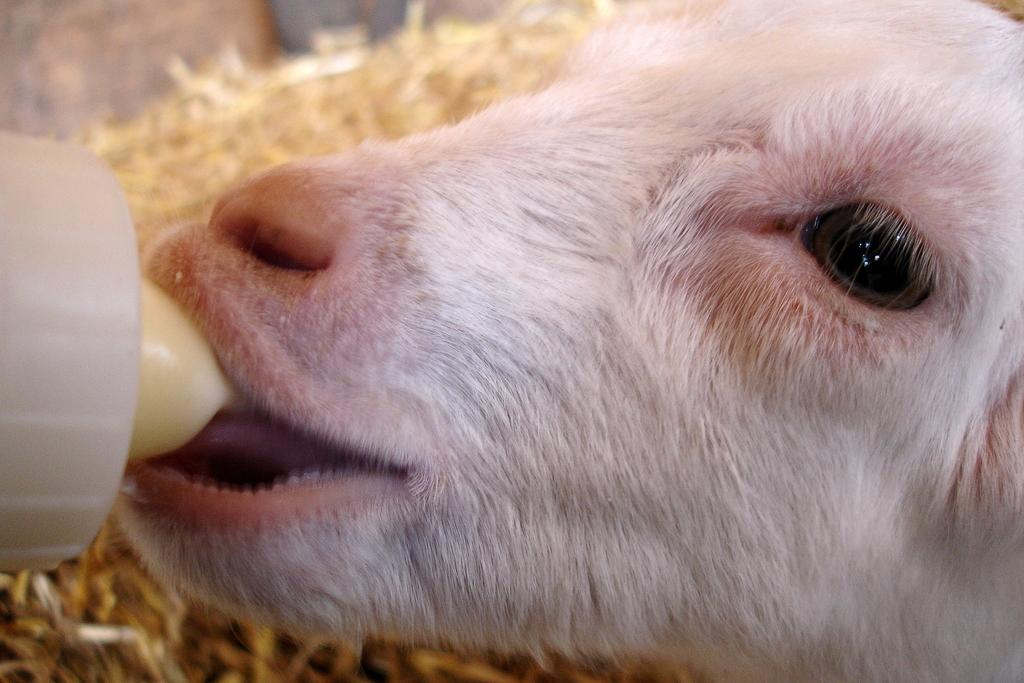What animal is present in the image? There is a dog in the image. What is the dog doing in the image? The dog is drinking milk. What type of account does the dog have in the image? There is no mention of an account in the image, as it features a dog drinking milk. 